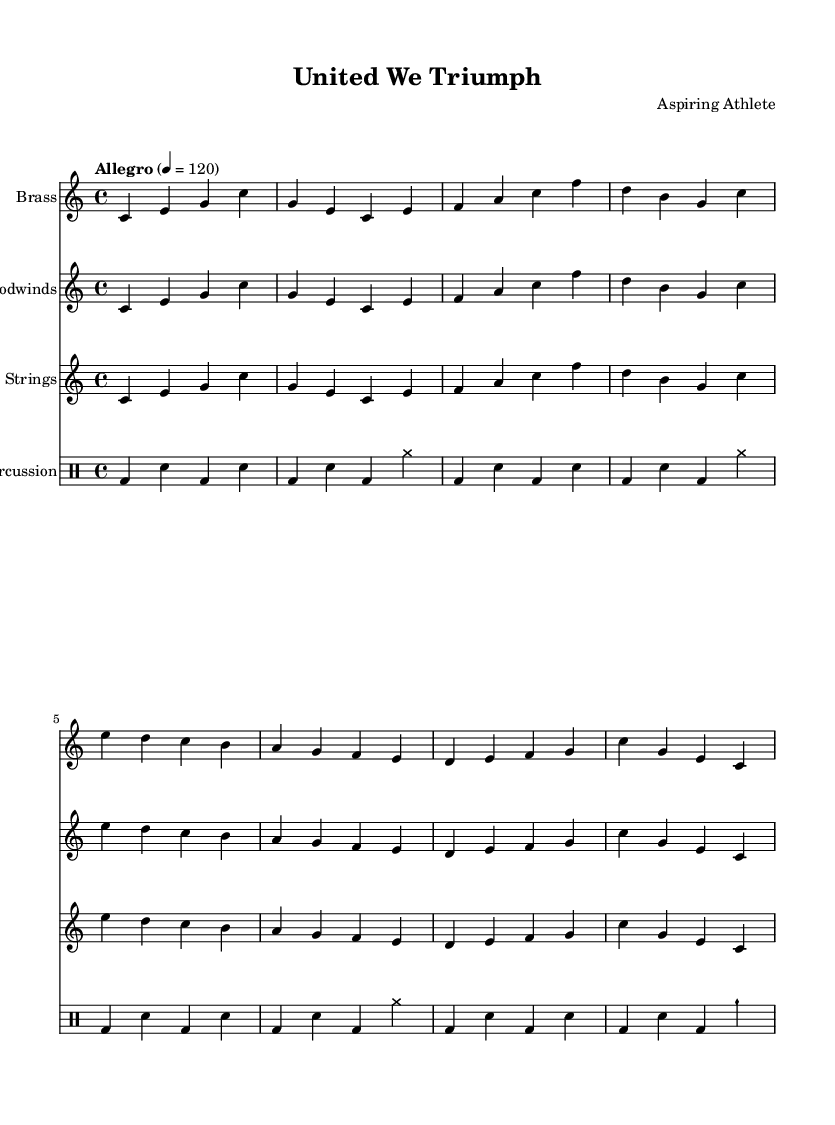What is the key signature of this music? The key signature appears at the beginning of the staff, indicating the key of C major, which has no sharps or flats.
Answer: C major What is the time signature of this music? The time signature is found at the beginning of the score and shows a 4 over 4. This indicates that there are four beats in each measure and a quarter note receives one beat.
Answer: 4/4 What is the tempo marking for this piece? The tempo marking, located above the staff, states "Allegro" with a metronome marking of 120, indicating a fast and lively pace.
Answer: Allegro How many instruments are featured in this symphony? By counting the distinct staffs and identifying the instrument names, there are four instruments: Brass, Woodwinds, Strings, and Percussion.
Answer: Four What rhythmic pattern is used in the percussion section? The percussion section uses a repeated pattern of bass drum and snare drum hits, with the addition of cymbals at certain points, which creates a lively rhythmic drive throughout.
Answer: Bass drum and snare pattern with cymbals Which musical form is mainly represented in this composition? The presence of a repeated main theme across different instrument sections and the structure of the music suggests a theme and variations form commonly used in symphonic compositions.
Answer: Theme and variations 